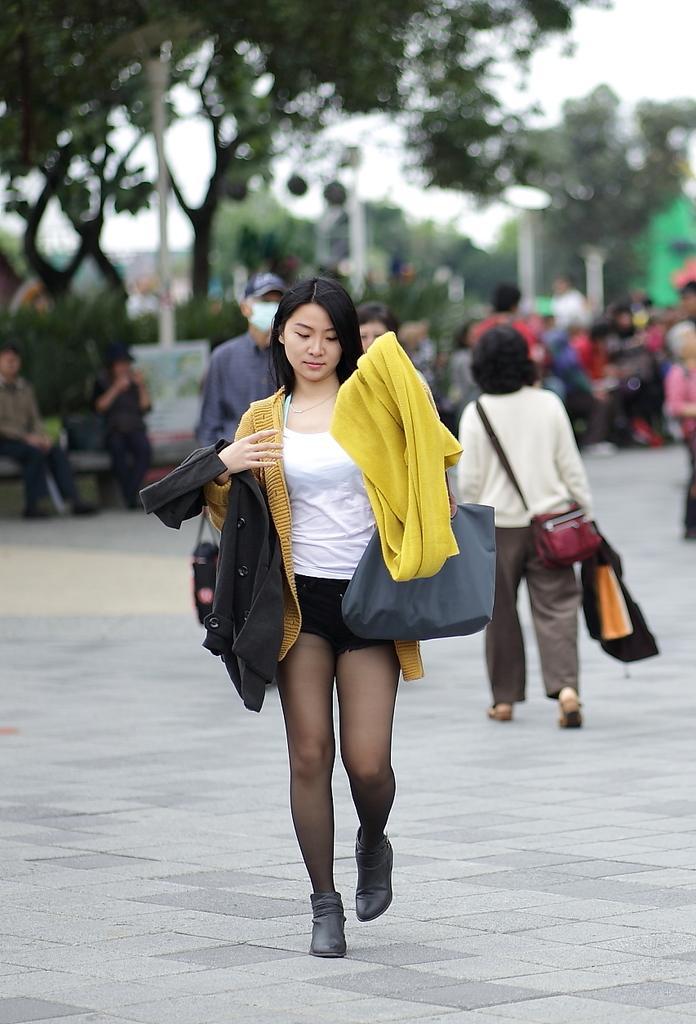In one or two sentences, can you explain what this image depicts? In this image I can see a person walking wearing yellow jacket, white shirt, holding a black color bag. At the background I can see few other persons walking, trees in green color and sky in white color. 